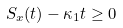Convert formula to latex. <formula><loc_0><loc_0><loc_500><loc_500>S _ { x } ( t ) - \kappa _ { 1 } t \geq 0</formula> 